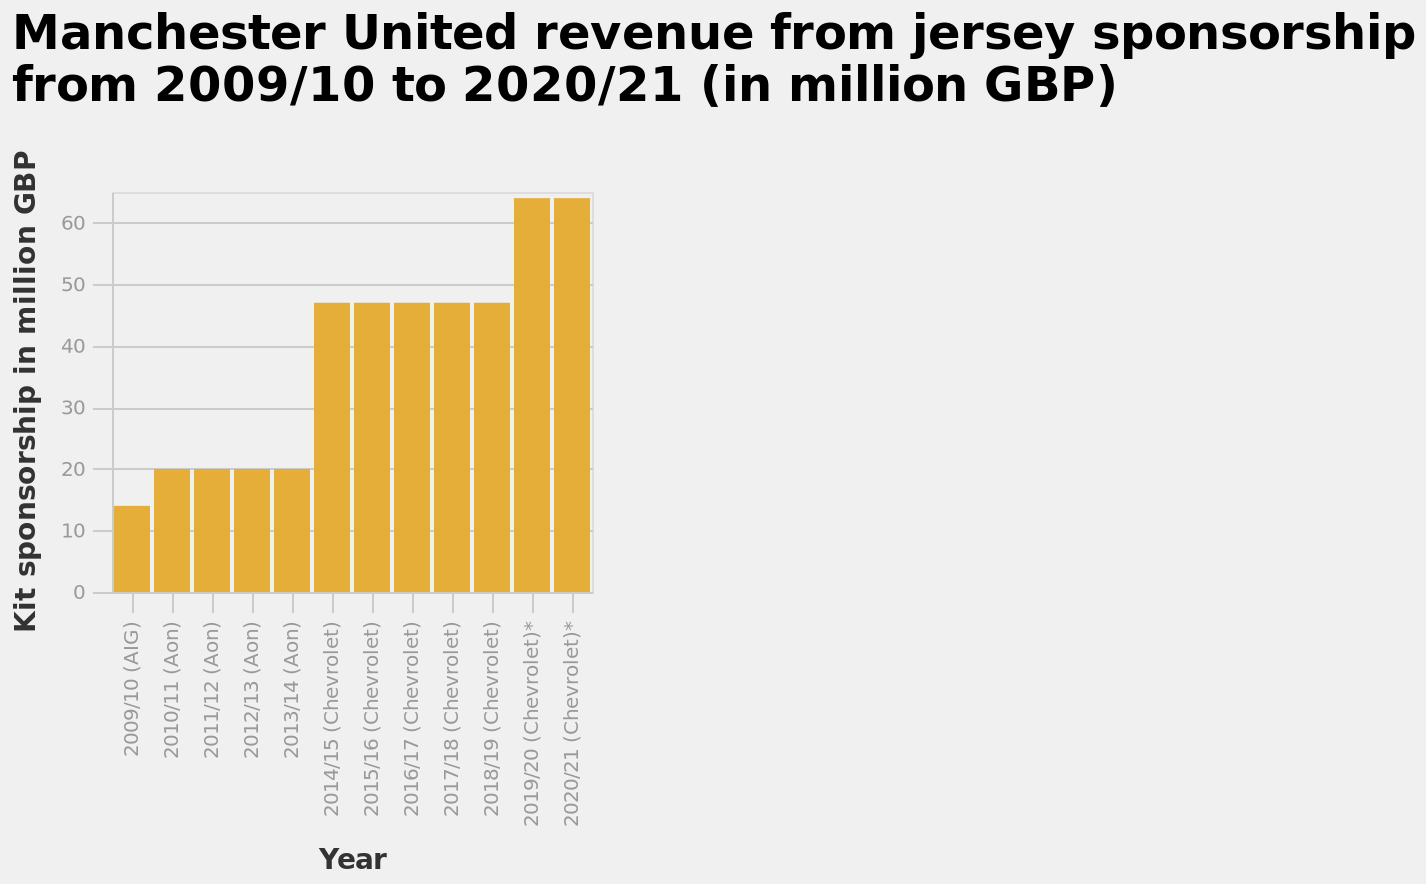<image>
please describe the details of the chart Here a bar plot is labeled Manchester United revenue from jersey sponsorship from 2009/10 to 2020/21 (in million GBP). A categorical scale starting with 2009/10 (AIG) and ending with 2020/21 (Chevrolet)* can be seen on the x-axis, marked Year. There is a linear scale of range 0 to 60 along the y-axis, labeled Kit sponsorship in million GBP. 